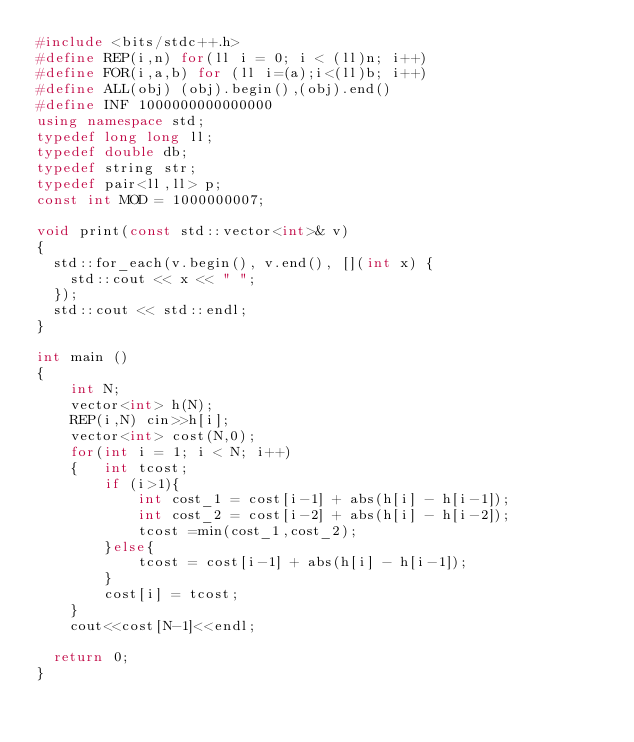<code> <loc_0><loc_0><loc_500><loc_500><_C++_>#include <bits/stdc++.h>
#define REP(i,n) for(ll i = 0; i < (ll)n; i++)
#define FOR(i,a,b) for (ll i=(a);i<(ll)b; i++)
#define ALL(obj) (obj).begin(),(obj).end()
#define INF 1000000000000000
using namespace std;
typedef long long ll;
typedef double db;
typedef string str;
typedef pair<ll,ll> p;
const int MOD = 1000000007;

void print(const std::vector<int>& v)
{
  std::for_each(v.begin(), v.end(), [](int x) {
    std::cout << x << " ";
  });
  std::cout << std::endl;
}

int main ()
{
    int N;
    vector<int> h(N);
    REP(i,N) cin>>h[i];
    vector<int> cost(N,0);
    for(int i = 1; i < N; i++)
    {   int tcost;
        if (i>1){
            int cost_1 = cost[i-1] + abs(h[i] - h[i-1]);
            int cost_2 = cost[i-2] + abs(h[i] - h[i-2]);
            tcost =min(cost_1,cost_2);
        }else{
            tcost = cost[i-1] + abs(h[i] - h[i-1]);
        }
        cost[i] = tcost;
    }
    cout<<cost[N-1]<<endl;

  return 0;
}</code> 